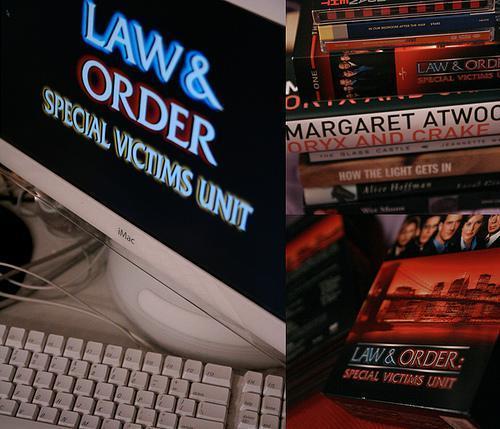How many books can be seen?
Give a very brief answer. 8. How many tvs are in the picture?
Give a very brief answer. 1. 